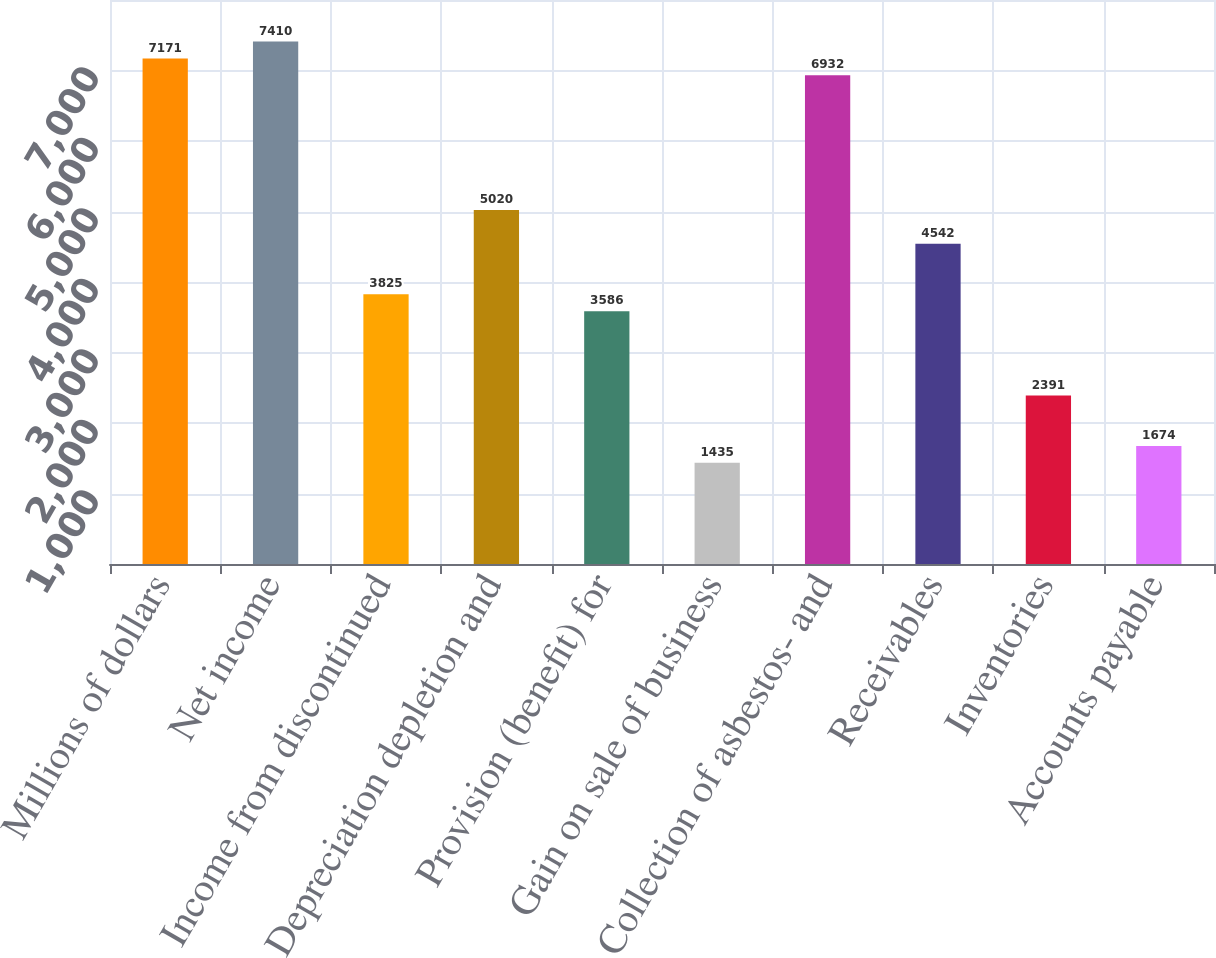<chart> <loc_0><loc_0><loc_500><loc_500><bar_chart><fcel>Millions of dollars<fcel>Net income<fcel>Income from discontinued<fcel>Depreciation depletion and<fcel>Provision (benefit) for<fcel>Gain on sale of business<fcel>Collection of asbestos- and<fcel>Receivables<fcel>Inventories<fcel>Accounts payable<nl><fcel>7171<fcel>7410<fcel>3825<fcel>5020<fcel>3586<fcel>1435<fcel>6932<fcel>4542<fcel>2391<fcel>1674<nl></chart> 